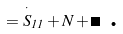Convert formula to latex. <formula><loc_0><loc_0><loc_500><loc_500>= \overset { \cdot } { S } _ { 1 1 } + N + \Lambda \text { .}</formula> 